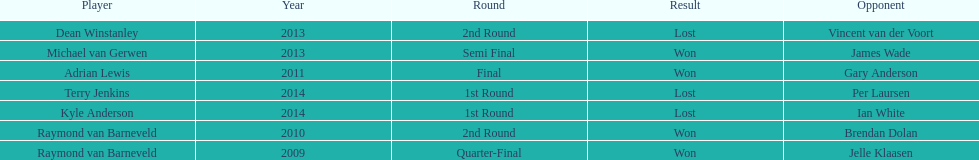Name a year with more than one game listed. 2013. Write the full table. {'header': ['Player', 'Year', 'Round', 'Result', 'Opponent'], 'rows': [['Dean Winstanley', '2013', '2nd Round', 'Lost', 'Vincent van der Voort'], ['Michael van Gerwen', '2013', 'Semi Final', 'Won', 'James Wade'], ['Adrian Lewis', '2011', 'Final', 'Won', 'Gary Anderson'], ['Terry Jenkins', '2014', '1st Round', 'Lost', 'Per Laursen'], ['Kyle Anderson', '2014', '1st Round', 'Lost', 'Ian White'], ['Raymond van Barneveld', '2010', '2nd Round', 'Won', 'Brendan Dolan'], ['Raymond van Barneveld', '2009', 'Quarter-Final', 'Won', 'Jelle Klaasen']]} 